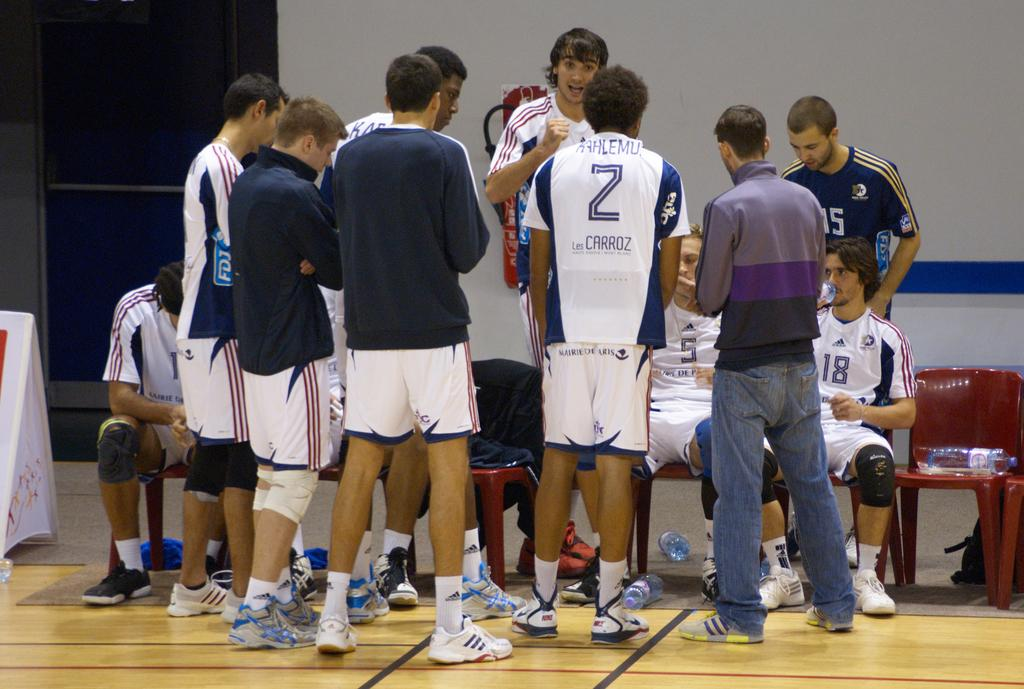<image>
Describe the image concisely. Members of a basketball team stand around, one has the writing "les carroz" on his shirt. 